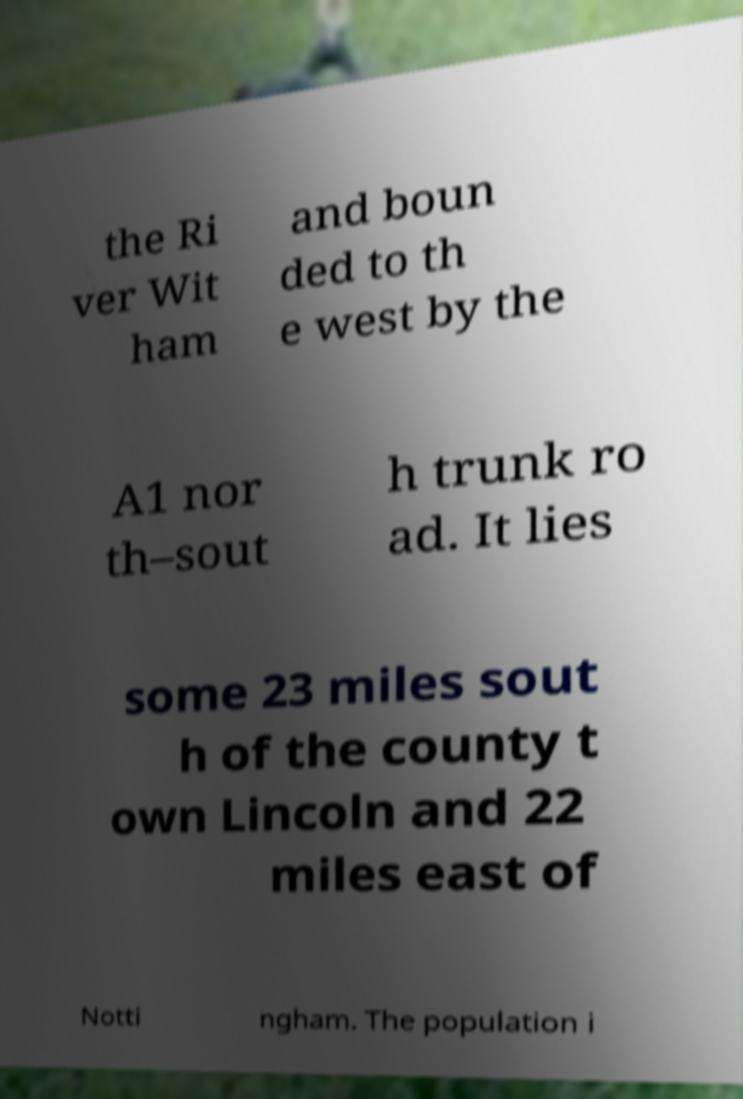Please read and relay the text visible in this image. What does it say? the Ri ver Wit ham and boun ded to th e west by the A1 nor th–sout h trunk ro ad. It lies some 23 miles sout h of the county t own Lincoln and 22 miles east of Notti ngham. The population i 